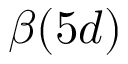<formula> <loc_0><loc_0><loc_500><loc_500>\beta ( 5 d )</formula> 